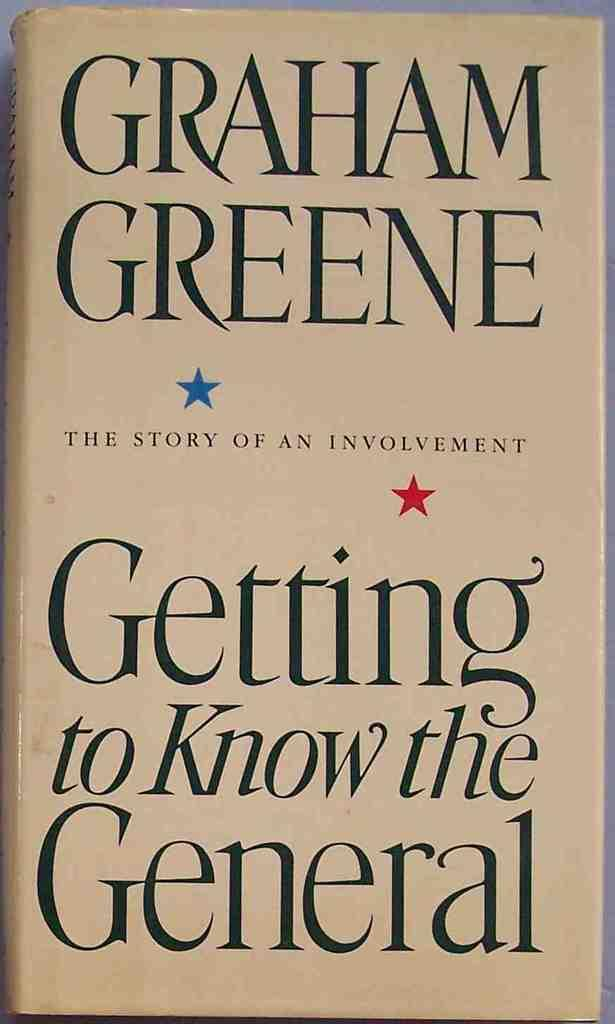Provide a one-sentence caption for the provided image. Graham Greene wrote Getting to Know the General, which has two small stars on the cover. 